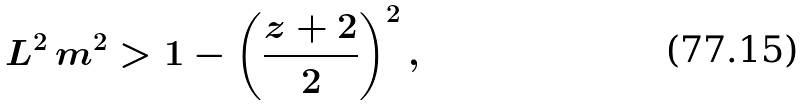<formula> <loc_0><loc_0><loc_500><loc_500>L ^ { 2 } \, m ^ { 2 } > 1 - \left ( \frac { z + 2 } { 2 } \right ) ^ { 2 } ,</formula> 